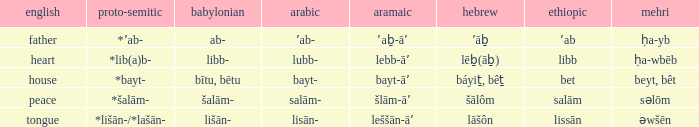If in arabic it is salām-, what is it in proto-semitic? *šalām-. 